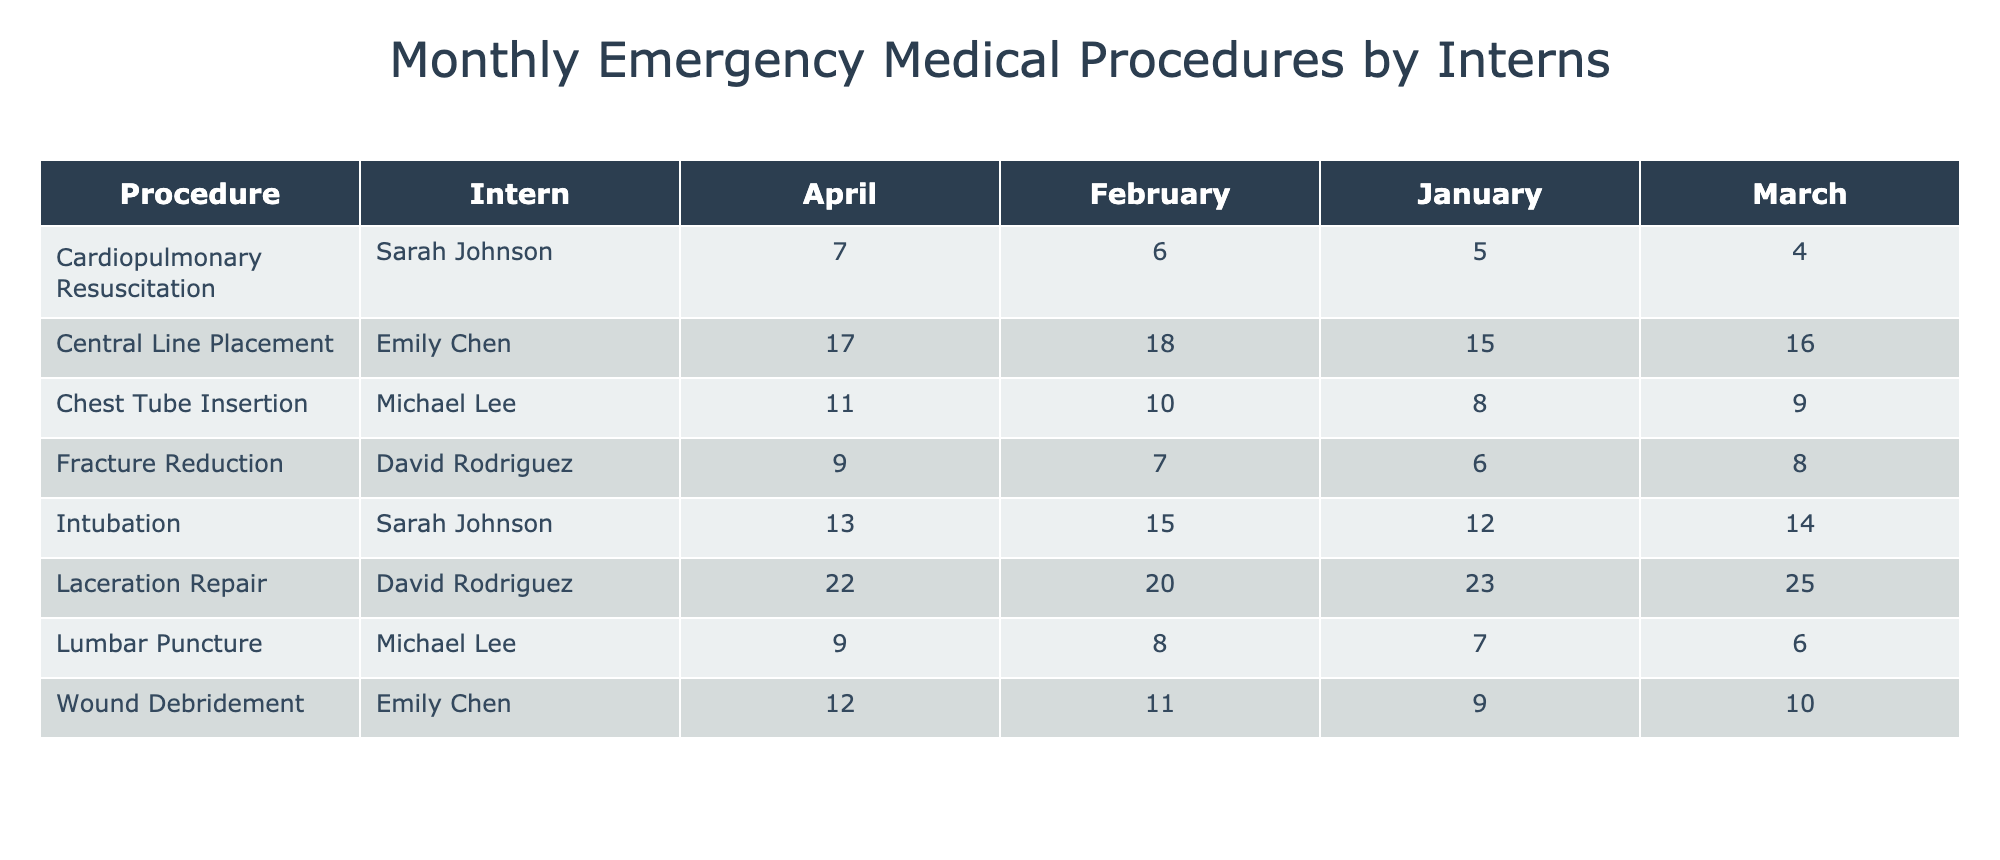What is the total number of Laceration Repairs performed by David Rodriguez over the four months? Looking at the table, I find the counts for Laceration Repair by David Rodriguez: 23 (January) + 20 (February) + 25 (March) + 22 (April). Adding these together gives 23 + 20 + 25 + 22 = 90.
Answer: 90 How many procedures did Sarah Johnson perform in February? In February, Sarah Johnson performed Intubation (15), Cardiopulmonary Resuscitation (6), and Laceration Repair (20). Summing them gives 15 + 6 + 20 = 41.
Answer: 41 Is the total number of Chest Tube Insertions performed by Michael Lee more than 25? Michael Lee performed 8 (January) + 10 (February) + 9 (March) + 11 (April), adding these gives 8 + 10 + 9 + 11 = 38, which is greater than 25.
Answer: Yes What procedure had the highest total count performed by Emily Chen? Looking at Emily Chen's procedures, the counts are: Central Line Placement (15 + 18 + 16 + 17 = 66), Wound Debridement (9 + 11 + 10 + 12 = 42). Central Line Placement has the higher total.
Answer: Central Line Placement Which intern performed the highest number of procedures overall in March? In March, the counts are: Sarah Johnson (Intubation 14 + CPR 4 = 18), Michael Lee (Chest Tube Insertion 9 + Lumbar Puncture 6 = 15), Emily Chen (Central Line Placement 16 + Wound Debridement 10 = 26), and David Rodriguez (Laceration Repair 25 + Fracture Reduction 8 = 33). David Rodriguez has the highest at 33.
Answer: David Rodriguez What is the average number of Intubations performed by Sarah Johnson per month? Sarah Johnson performed Intubation: 12 (January), 15 (February), 14 (March), 13 (April). The total is 12 + 15 + 14 + 13 = 54, and there are 4 months. The average is 54 / 4 = 13.5.
Answer: 13.5 Which procedure consistently had the lowest count from January to April? By reviewing the table, Wound Debridement had counts of 9 (January), 11 (February), 10 (March), and 12 (April). This is lower than any other procedure for each month.
Answer: Wound Debridement How many more Central Line Placements did Emily Chen perform in February compared to April? Emily Chen performed 18 Central Line Placements in February and 17 in April. The difference is 18 - 17 = 1.
Answer: 1 In which month did David Rodriguez perform the least number of Fracture Reductions? The counts of Fracture Reductions by David Rodriguez are: 6 (January), 7 (February), 8 (March), and 9 (April). The least is in January with 6.
Answer: January What is the total number of procedures performed by Michael Lee across all four months? Adding Michael Lee's total procedures gives: Chest Tube Insertion (8 + 10 + 9 + 11 = 38) and Lumbar Puncture (7 + 8 + 6 + 9 = 30). Therefore, 38 + 30 = 68 total procedures.
Answer: 68 Which intern had the highest count of procedures in January? For January, the totals are: Sarah Johnson (Intubation 12 + CPR 5 = 17), Michael Lee (Chest Tube Insertion 8 + Lumbar Puncture 7 = 15), Emily Chen (Wound Debridement 9), and David Rodriguez (Laceration Repair 23 + Fracture Reduction 6 = 29). David Rodriguez had the highest count at 29.
Answer: David Rodriguez 